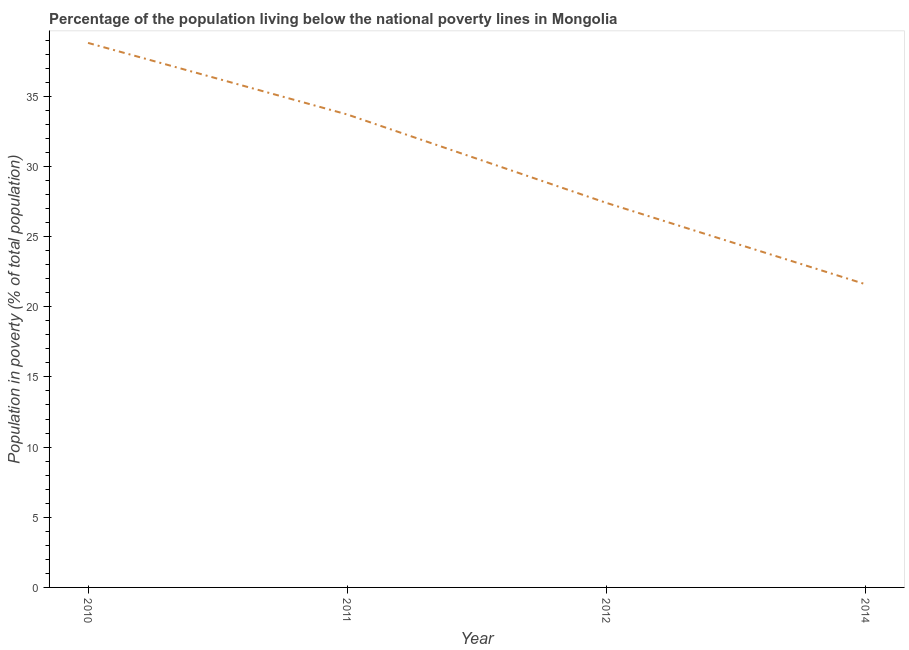What is the percentage of population living below poverty line in 2012?
Make the answer very short. 27.4. Across all years, what is the maximum percentage of population living below poverty line?
Offer a terse response. 38.8. Across all years, what is the minimum percentage of population living below poverty line?
Your answer should be compact. 21.6. In which year was the percentage of population living below poverty line minimum?
Keep it short and to the point. 2014. What is the sum of the percentage of population living below poverty line?
Your answer should be compact. 121.5. What is the difference between the percentage of population living below poverty line in 2012 and 2014?
Keep it short and to the point. 5.8. What is the average percentage of population living below poverty line per year?
Make the answer very short. 30.38. What is the median percentage of population living below poverty line?
Make the answer very short. 30.55. In how many years, is the percentage of population living below poverty line greater than 29 %?
Your response must be concise. 2. Do a majority of the years between 2011 and 2014 (inclusive) have percentage of population living below poverty line greater than 3 %?
Your response must be concise. Yes. What is the ratio of the percentage of population living below poverty line in 2012 to that in 2014?
Offer a terse response. 1.27. Is the difference between the percentage of population living below poverty line in 2010 and 2014 greater than the difference between any two years?
Offer a terse response. Yes. What is the difference between the highest and the second highest percentage of population living below poverty line?
Your answer should be compact. 5.1. What is the difference between the highest and the lowest percentage of population living below poverty line?
Give a very brief answer. 17.2. Does the percentage of population living below poverty line monotonically increase over the years?
Ensure brevity in your answer.  No. How many years are there in the graph?
Make the answer very short. 4. What is the difference between two consecutive major ticks on the Y-axis?
Provide a succinct answer. 5. What is the title of the graph?
Offer a very short reply. Percentage of the population living below the national poverty lines in Mongolia. What is the label or title of the X-axis?
Keep it short and to the point. Year. What is the label or title of the Y-axis?
Ensure brevity in your answer.  Population in poverty (% of total population). What is the Population in poverty (% of total population) in 2010?
Make the answer very short. 38.8. What is the Population in poverty (% of total population) of 2011?
Offer a terse response. 33.7. What is the Population in poverty (% of total population) in 2012?
Offer a very short reply. 27.4. What is the Population in poverty (% of total population) in 2014?
Provide a short and direct response. 21.6. What is the difference between the Population in poverty (% of total population) in 2011 and 2014?
Give a very brief answer. 12.1. What is the ratio of the Population in poverty (% of total population) in 2010 to that in 2011?
Make the answer very short. 1.15. What is the ratio of the Population in poverty (% of total population) in 2010 to that in 2012?
Make the answer very short. 1.42. What is the ratio of the Population in poverty (% of total population) in 2010 to that in 2014?
Ensure brevity in your answer.  1.8. What is the ratio of the Population in poverty (% of total population) in 2011 to that in 2012?
Provide a short and direct response. 1.23. What is the ratio of the Population in poverty (% of total population) in 2011 to that in 2014?
Offer a terse response. 1.56. What is the ratio of the Population in poverty (% of total population) in 2012 to that in 2014?
Offer a very short reply. 1.27. 